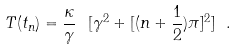Convert formula to latex. <formula><loc_0><loc_0><loc_500><loc_500>T ( t _ { n } ) = \frac { \kappa } { \gamma } \ [ \gamma ^ { 2 } + [ ( n + \frac { 1 } { 2 } ) \pi ] ^ { 2 } ] \ .</formula> 